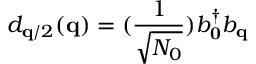Convert formula to latex. <formula><loc_0><loc_0><loc_500><loc_500>d _ { { q } / 2 } ( { q } ) = ( \frac { 1 } { \sqrt { N _ { 0 } } } ) b _ { 0 } ^ { \dagger } b _ { q }</formula> 